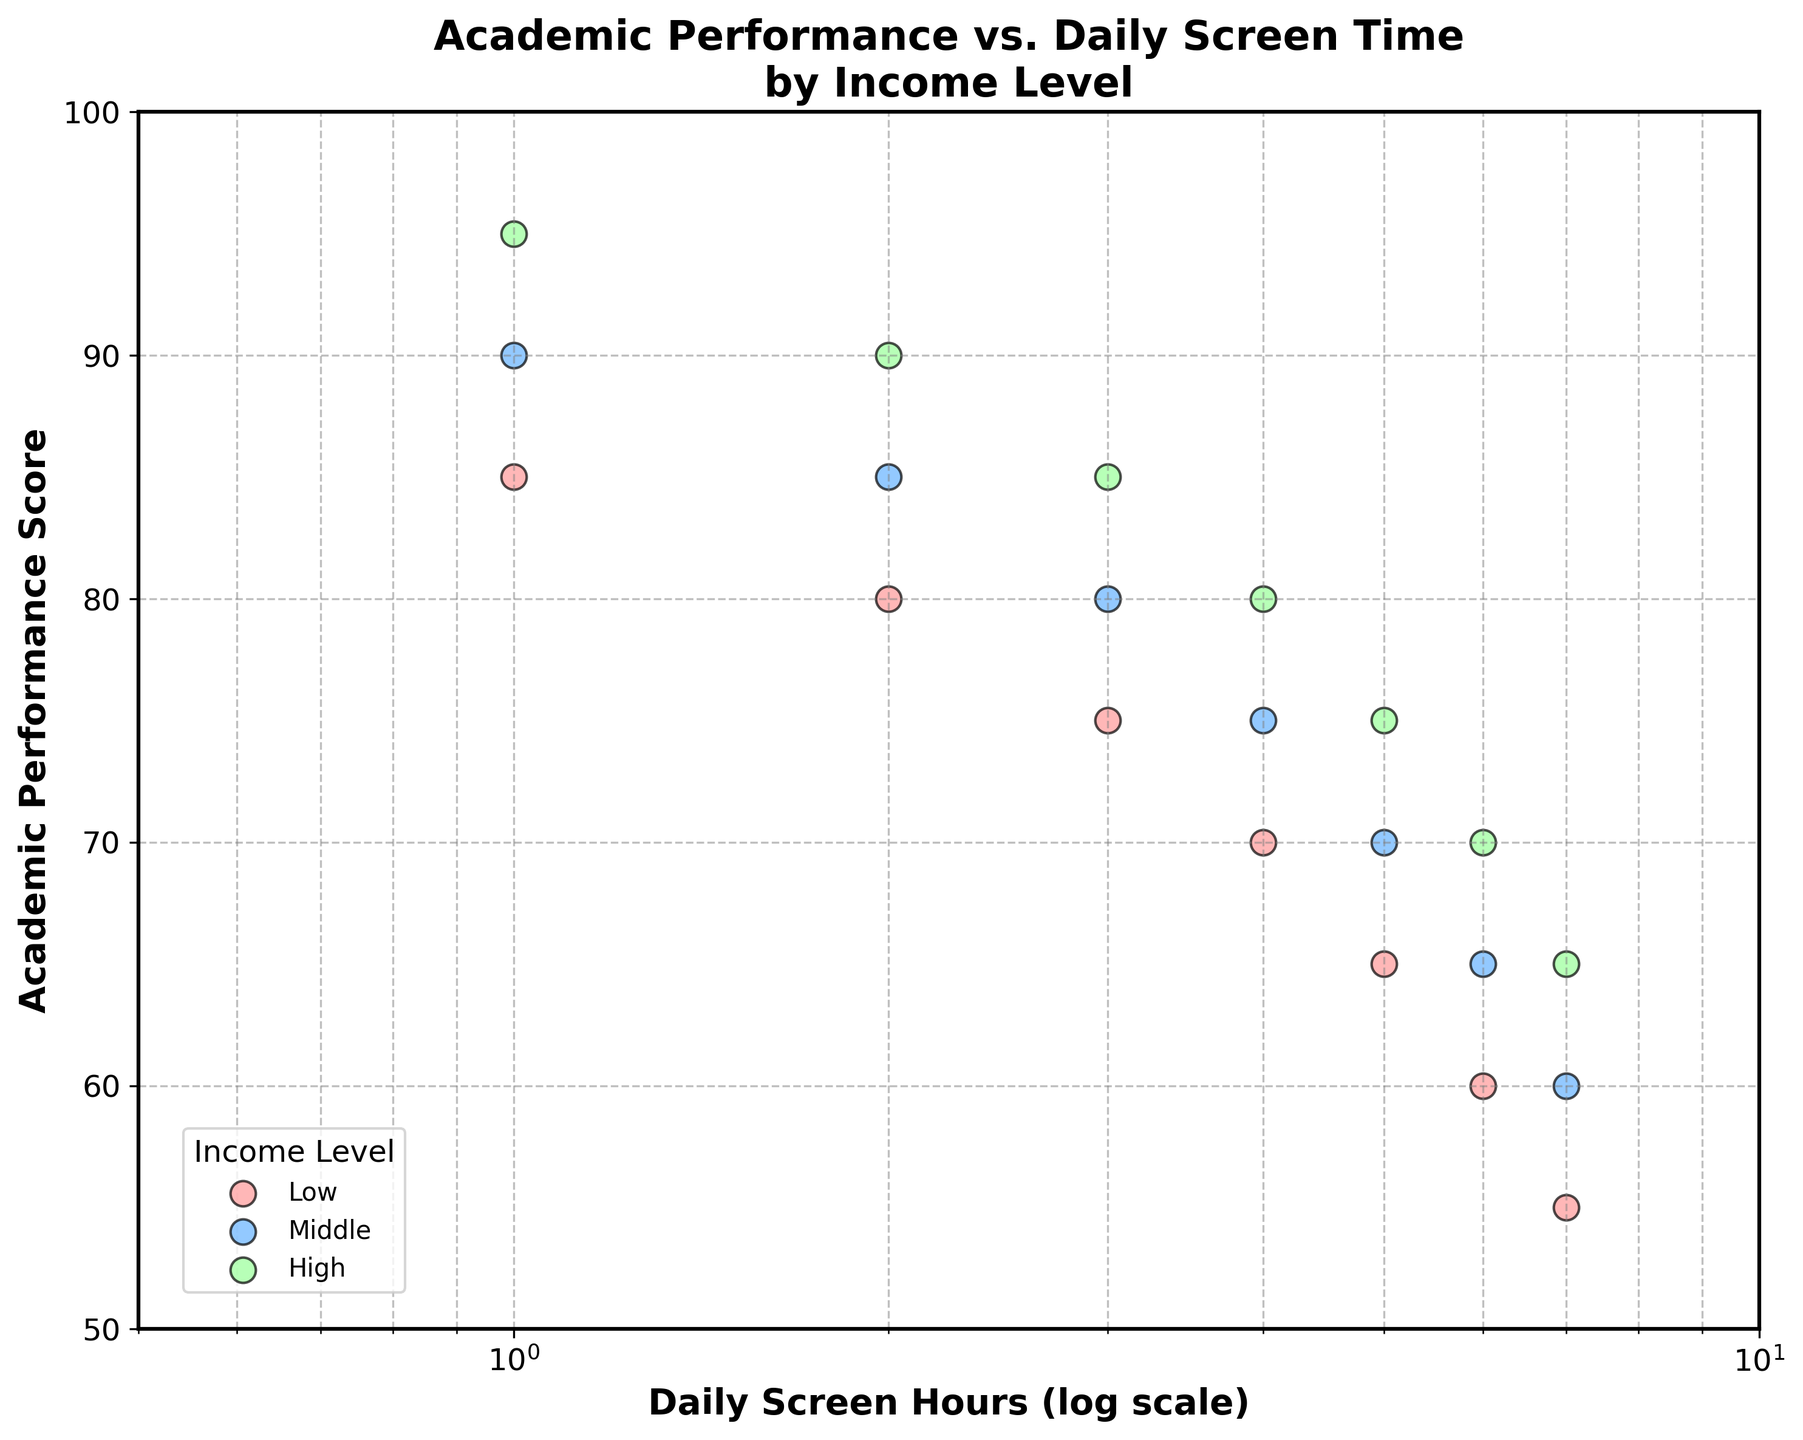What's the title of the figure? The title of the figure appears at the top and it can be read directly. The title is "Academic Performance vs. Daily Screen Time by Income Level".
Answer: Academic Performance vs. Daily Screen Time by Income Level What is the x-axis label? The x-axis label can be found directly below the horizontal axis. It is written as "Daily Screen Hours (log scale)".
Answer: Daily Screen Hours (log scale) What is the y-axis label? The y-axis label is placed to the left of the vertical axis. It is labeled as "Academic Performance Score".
Answer: Academic Performance Score Which income level shows the highest academic performance score for 1 hour of daily screen time? Look for the data points at 1 hour of daily screen time and identify the highest academic performance score. The green color points represent the High-income level, and the highest score there is 95.
Answer: High How many data points are there for each income level? Count the number of points per income level. Each income level shows data for 1 to 7 daily screen hours. Therefore, there are 7 data points for Low, 7 for Middle, and 7 for High-income levels.
Answer: 7 for each income level Is there a trend in academic performance scores as daily screen time increases? Observe the data points for each income level and how they change as daily screen time increases. All income levels' academic performance scores tend to decrease with increasing daily screen time.
Answer: Decrease Which income level has the steepest decline in academic performance score from 1 to 7 daily screen hours? Compare the differences in academic performance scores between 1 and 7 daily screen hours for Low, Middle, and High-income levels. The Low-income level drops from 85 to 55, which is a 30-point difference. The Middle-income level drops from 90 to 60, a 30-point difference. The High-income level drops from 95 to 65, a 30-point difference. They all have an equal decline.
Answer: All have equal decline Do the colors of the points correspond to different income levels? Identify whether there is a distinct color for each income level. Yes, red represents Low, blue represents Middle, and green represents High-income levels.
Answer: Yes At 2 hours of daily screen time, which income level has the highest academic performance score? Look at the data points corresponding to 2 hours of daily screen time and find the highest score among them. The High-income level has the highest score of 90 at 2 hours.
Answer: High 